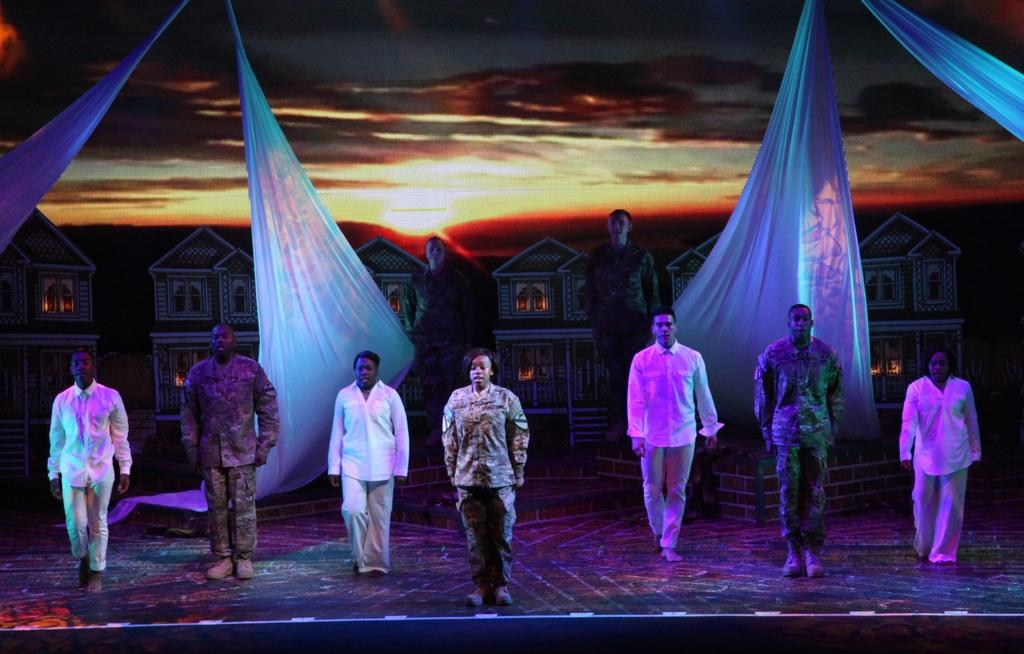What are the people in the image doing? The people are standing on the stage. What can be seen in the background behind the stage? There are curtains and houses in the background. How would you describe the weather based on the image? The sky is cloudy in the image. What type of chalk is being used by the people on the stage? There is no chalk present in the image, and the people on the stage are not using any chalk. How does the boot move around on the stage? There is no boot present in the image, so it cannot be determined how it would move around. 